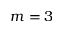<formula> <loc_0><loc_0><loc_500><loc_500>m = 3</formula> 